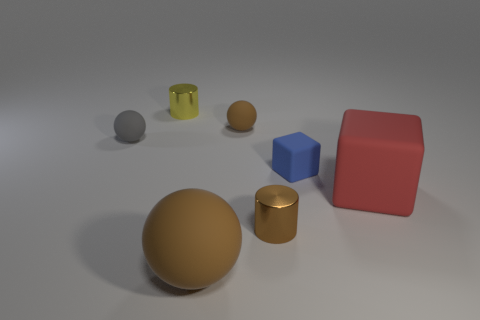What is the material of the big ball?
Ensure brevity in your answer.  Rubber. The thing that is left of the brown cylinder and in front of the blue block is what color?
Keep it short and to the point. Brown. Are there an equal number of big balls behind the yellow metallic cylinder and tiny metal things that are behind the small brown ball?
Your answer should be very brief. No. There is another cube that is the same material as the large red block; what color is it?
Your answer should be compact. Blue. There is a big sphere; is its color the same as the cylinder in front of the blue block?
Your answer should be compact. Yes. There is a small cylinder that is on the left side of the tiny cylinder in front of the large cube; are there any tiny metallic cylinders that are in front of it?
Offer a terse response. Yes. There is a thing that is the same material as the yellow cylinder; what shape is it?
Your answer should be very brief. Cylinder. What is the shape of the gray matte object?
Your answer should be compact. Sphere. There is a shiny thing that is behind the small gray matte object; does it have the same shape as the brown shiny object?
Your answer should be compact. Yes. Are there more gray spheres that are to the right of the gray ball than gray rubber objects on the right side of the small blue block?
Make the answer very short. No. 